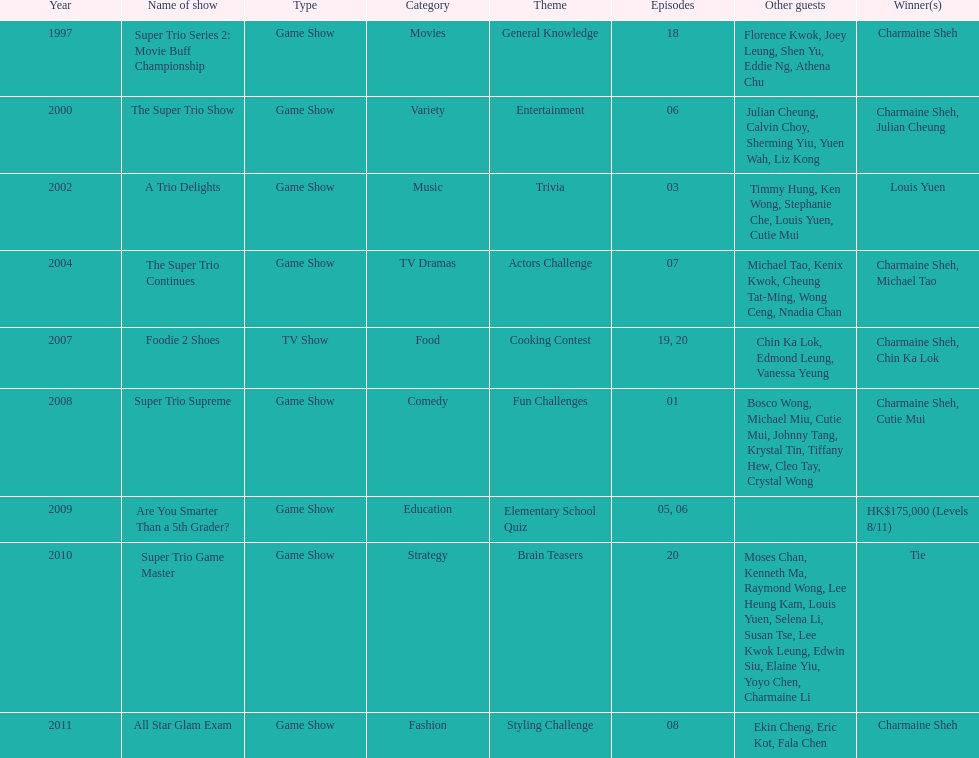What year was the only year were a tie occurred? 2010. 